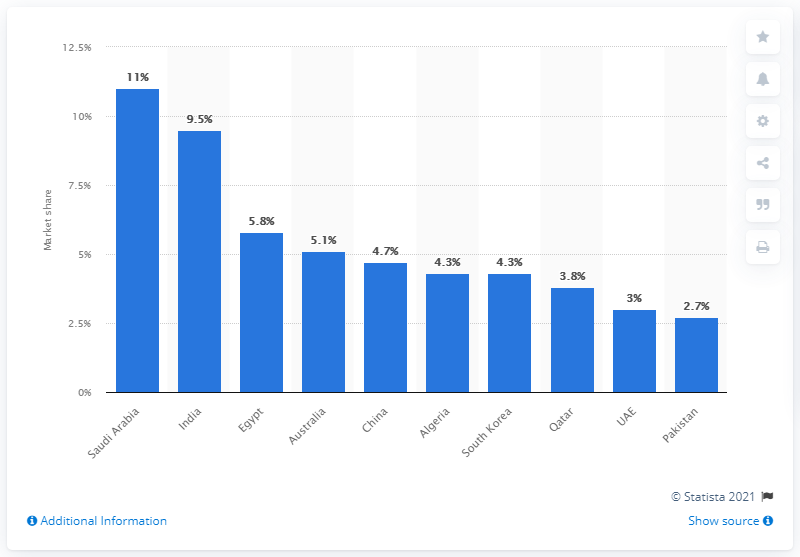Specify some key components in this picture. According to data from 2016 to 2020, Saudi Arabia was the largest importer of major arms. During the period of 2016 to 2020, Saudi Arabia accounted for approximately 11% of the global market. 